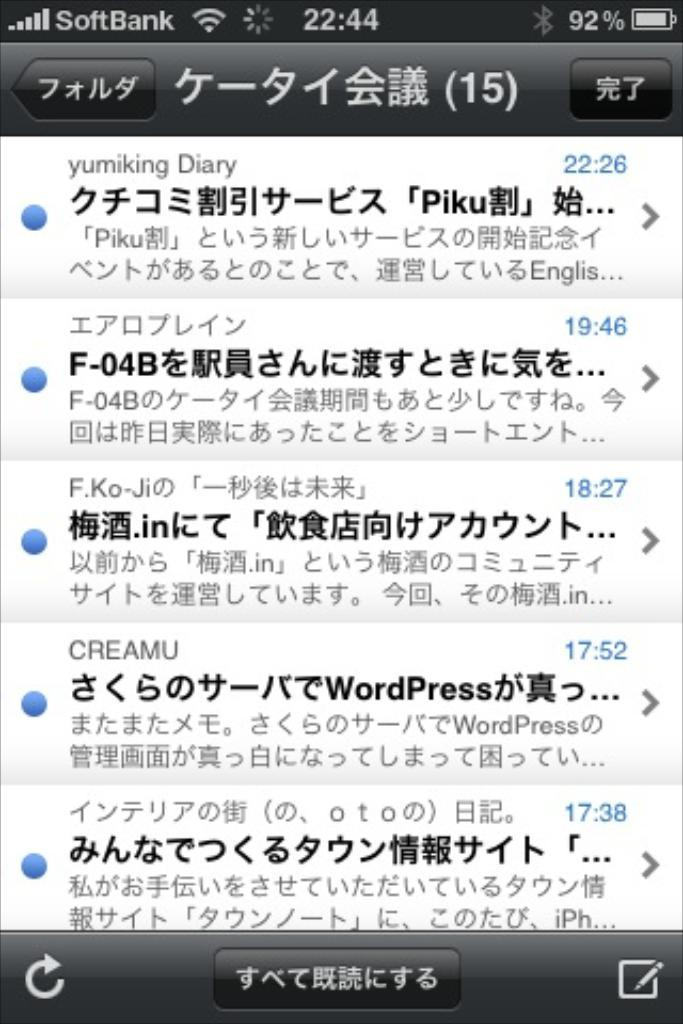<image>
Describe the image concisely. a screenshot of an iphone screen that says 'softbank' on the top left 